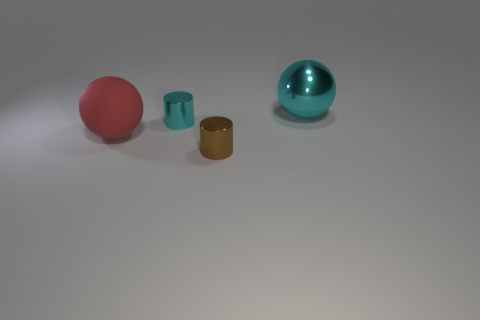Add 1 red spheres. How many objects exist? 5 Add 4 cyan metallic balls. How many cyan metallic balls are left? 5 Add 2 big cyan balls. How many big cyan balls exist? 3 Subtract 0 green blocks. How many objects are left? 4 Subtract all small brown shiny objects. Subtract all cyan metal objects. How many objects are left? 1 